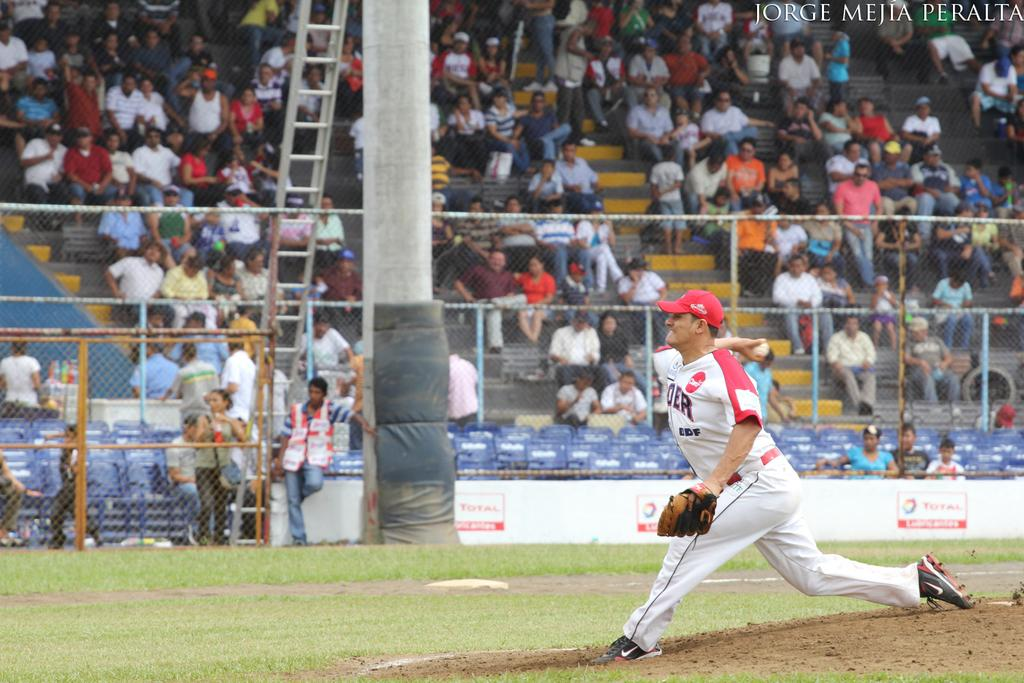<image>
Describe the image concisely. A pitcher gets ready to throw a ball with ads for Total in the background. 